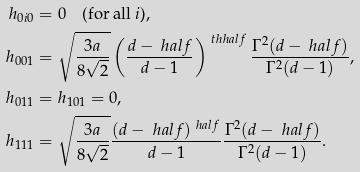Convert formula to latex. <formula><loc_0><loc_0><loc_500><loc_500>h _ { 0 i 0 } & = 0 \quad \text {(for all $i$)} , \\ h _ { 0 0 1 } & = \sqrt { \frac { 3 a } { 8 \sqrt { 2 } } } \left ( \frac { d - \ h a l f } { d - 1 } \right ) ^ { \ t h h a l f } \frac { \Gamma ^ { 2 } ( d - \ h a l f ) } { \Gamma ^ { 2 } ( d - 1 ) } , \\ h _ { 0 1 1 } & = h _ { 1 0 1 } = 0 , \\ h _ { 1 1 1 } & = \sqrt { \frac { 3 a } { 8 \sqrt { 2 } } } \frac { ( d - \ h a l f ) ^ { \ h a l f } } { d - 1 } \frac { \Gamma ^ { 2 } ( d - \ h a l f ) } { \Gamma ^ { 2 } ( d - 1 ) } .</formula> 